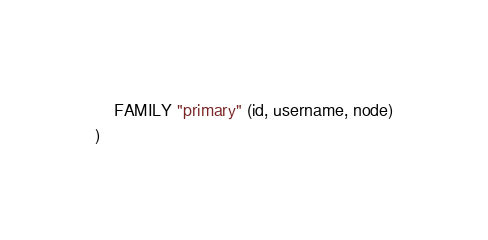Convert code to text. <code><loc_0><loc_0><loc_500><loc_500><_SQL_>	FAMILY "primary" (id, username, node)
)</code> 